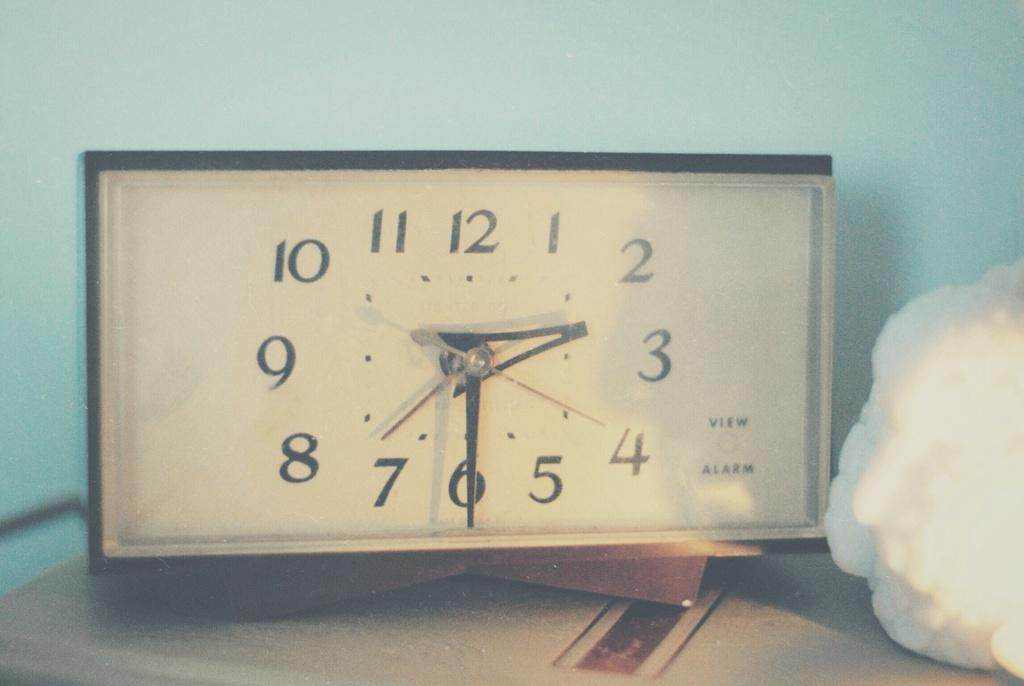<image>
Describe the image concisely. An analog clock sits on a table with the Alarm off. 